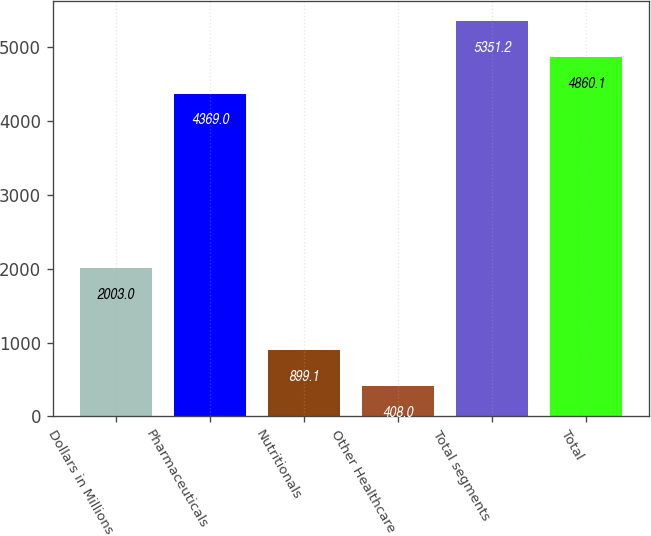Convert chart. <chart><loc_0><loc_0><loc_500><loc_500><bar_chart><fcel>Dollars in Millions<fcel>Pharmaceuticals<fcel>Nutritionals<fcel>Other Healthcare<fcel>Total segments<fcel>Total<nl><fcel>2003<fcel>4369<fcel>899.1<fcel>408<fcel>5351.2<fcel>4860.1<nl></chart> 